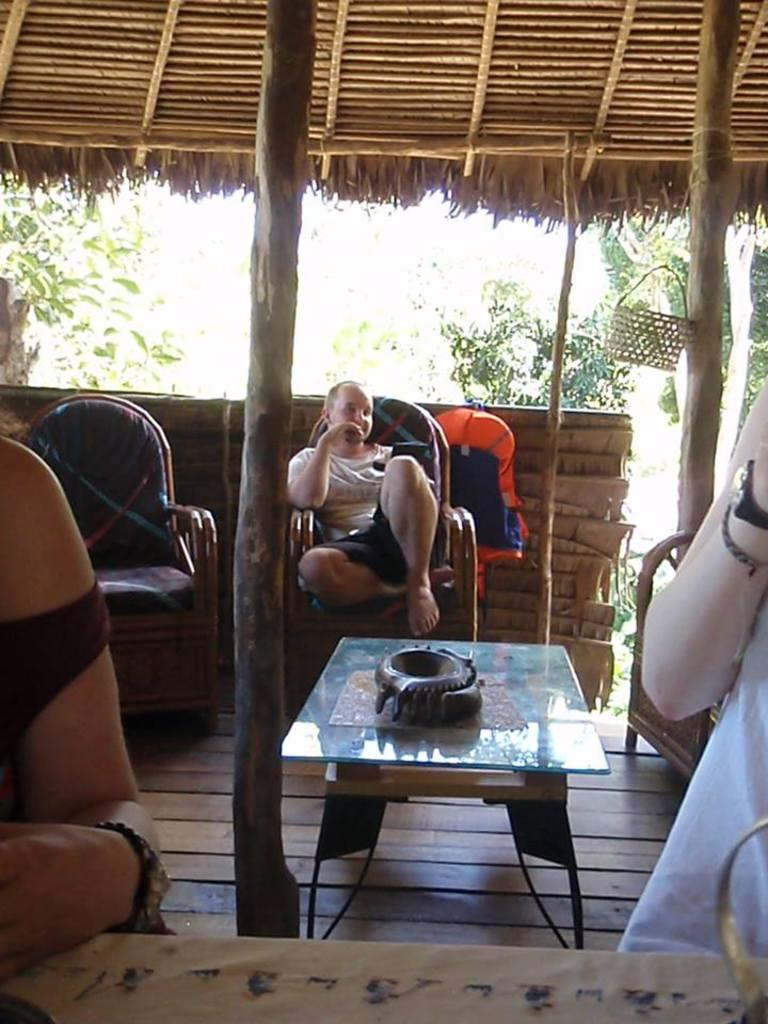What is the seated person doing in the image? There is a person sitting in a chair in the image. What object is present in the image that the seated person might use? There is a table in the image that the seated person might use. How many people are visible in the image besides the seated person? There are two persons in front of the seated person in the image. What type of natural scenery can be seen in the background of the image? There are trees in the background of the image. What type of island is visible in the image? There is no island present in the image; it features a person sitting in a chair, a table, two persons in front, and trees in the background. 